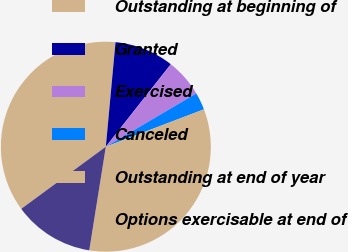<chart> <loc_0><loc_0><loc_500><loc_500><pie_chart><fcel>Outstanding at beginning of<fcel>Granted<fcel>Exercised<fcel>Canceled<fcel>Outstanding at end of year<fcel>Options exercisable at end of<nl><fcel>36.55%<fcel>9.15%<fcel>5.91%<fcel>2.68%<fcel>33.31%<fcel>12.39%<nl></chart> 